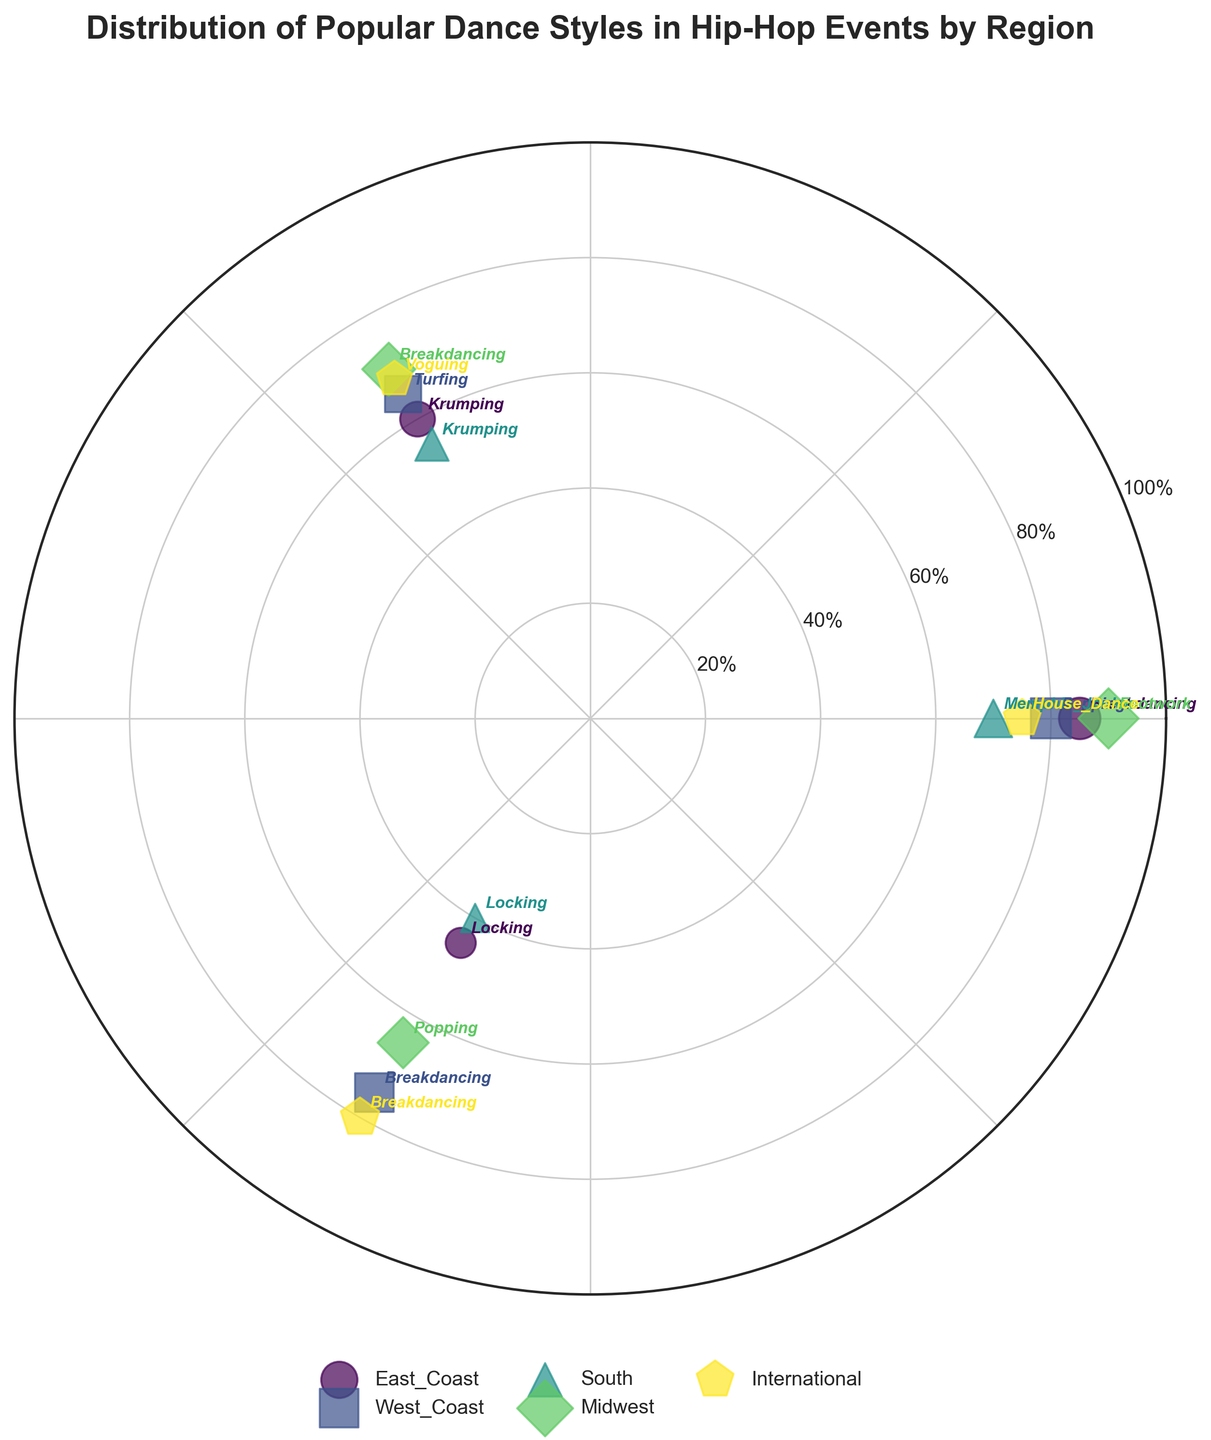what is the title of the figure? The title of the figure is usually written above the chart and gives a brief description of what the chart represents. Here, it states "Distribution of Popular Dance Styles in Hip-Hop Events by Region"
Answer: Distribution of Popular Dance Styles in Hip-Hop Events by Region which region has the highest popularity of breakdancing? To answer this, we locate all the data points labeled "Breakdancing" and compare their popularity scores. The regions and scores are: East Coast (85), West Coast (75), Midwest (70), International (80). The highest is 85, corresponding to the East Coast.
Answer: East Coast what is the average popularity of krumping across all regions? First, identify the popularity scores of Krumping in East Coast (60), South (55). Sum these values: 60 + 55 = 115. Since we have 2 regions, the average is 115 / 2 = 57.5
Answer: 57.5 which dance style has the highest popularity score in the Midwest region? Focus on the Midwest region and note the popularity scores of its dance styles: Footwork (90), Breakdancing (70), Popping (65). The highest score is 90 for Footwork.
Answer: Footwork which region has the most diverse set of dance styles? Diversity can be assessed by counting the distinct dance styles in each region. East Coast has 3 styles (Breakdancing, Krumping, Locking), West Coast has 3 (Popping, Turfing, Breakdancing), South has 3 (Memphis Jookin, Krumping, Locking), and Midwest has 3 (Footwork, Breakdancing, Popping). International has 3 styles (House Dance, Voguing, Breakdancing). Since they all have the same number, none is more diverse.
Answer: They are equally diverse which dance style is more popular internationally, voguing or house dance? Look for the popularity scores in the International region: Voguing (68), House Dance (75). Since 75 is higher than 68, House Dance is more popular.
Answer: House Dance what is the combined popularity score of popping in east coast and midwest? Identify the popularity scores of Popping in the East Coast and Midwest: East Coast does not have Popping scores, but Midwest does (65). Thus, combined score is 0 (East Coast) + 65 (Midwest) = 65.
Answer: 65 which dance style has the lowest popularity score in the South? Look at the South region's dance styles and their popularity scores: Memphis Jookin (70), Krumping (55), Locking (40). The lowest score is 40 for Locking.
Answer: Locking how many dance styles are plotted in the figure? Count all distinct dance styles listed in the data: Breakdancing, Krumping, Locking, Popping, Turfing, Memphis Jookin, Footwork, House Dance, Voguing. A total of 9 distinct dance styles are plotted.
Answer: 9 